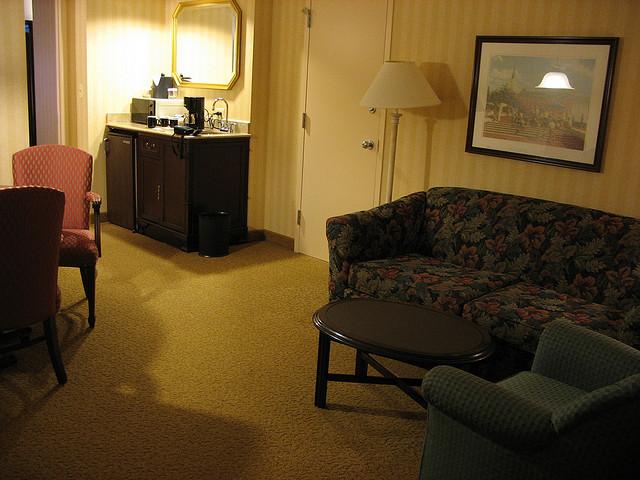What pattern is on the couch?
Short answer required. Floral. Is the lamp on?
Quick response, please. No. What color is the armchair?
Quick response, please. Red. What color is the sofa cushion?
Write a very short answer. Green. What type of room is this?
Short answer required. Living room. What object appears to be reflected in the mirror on right part of the page?
Answer briefly. Lamp. What color is the carpet?
Write a very short answer. Brown. What is reflected in the mirror?
Be succinct. Light. Which seat would be the least comfortable?
Write a very short answer. Red chair. Is this a hotel room?
Give a very brief answer. Yes. 